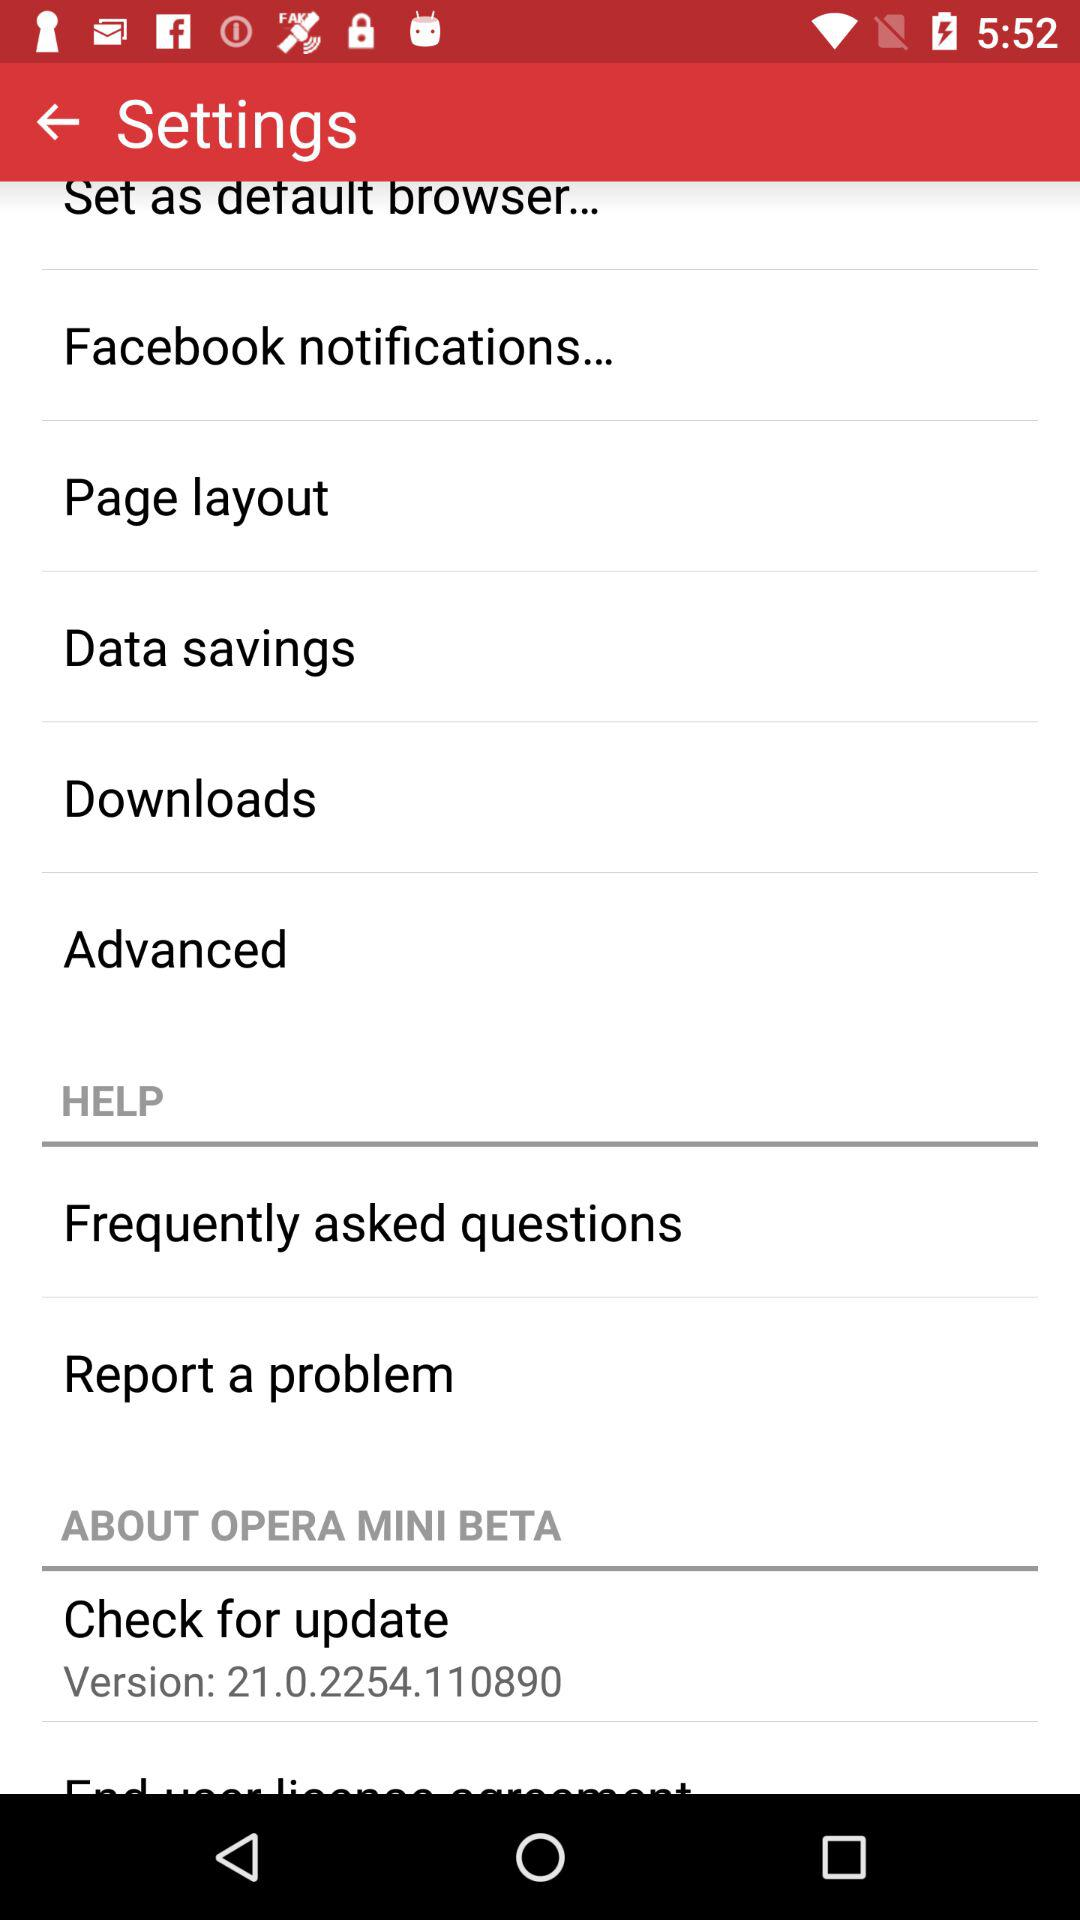What version is available for updates? The available version is 21.0.2254.110890. 